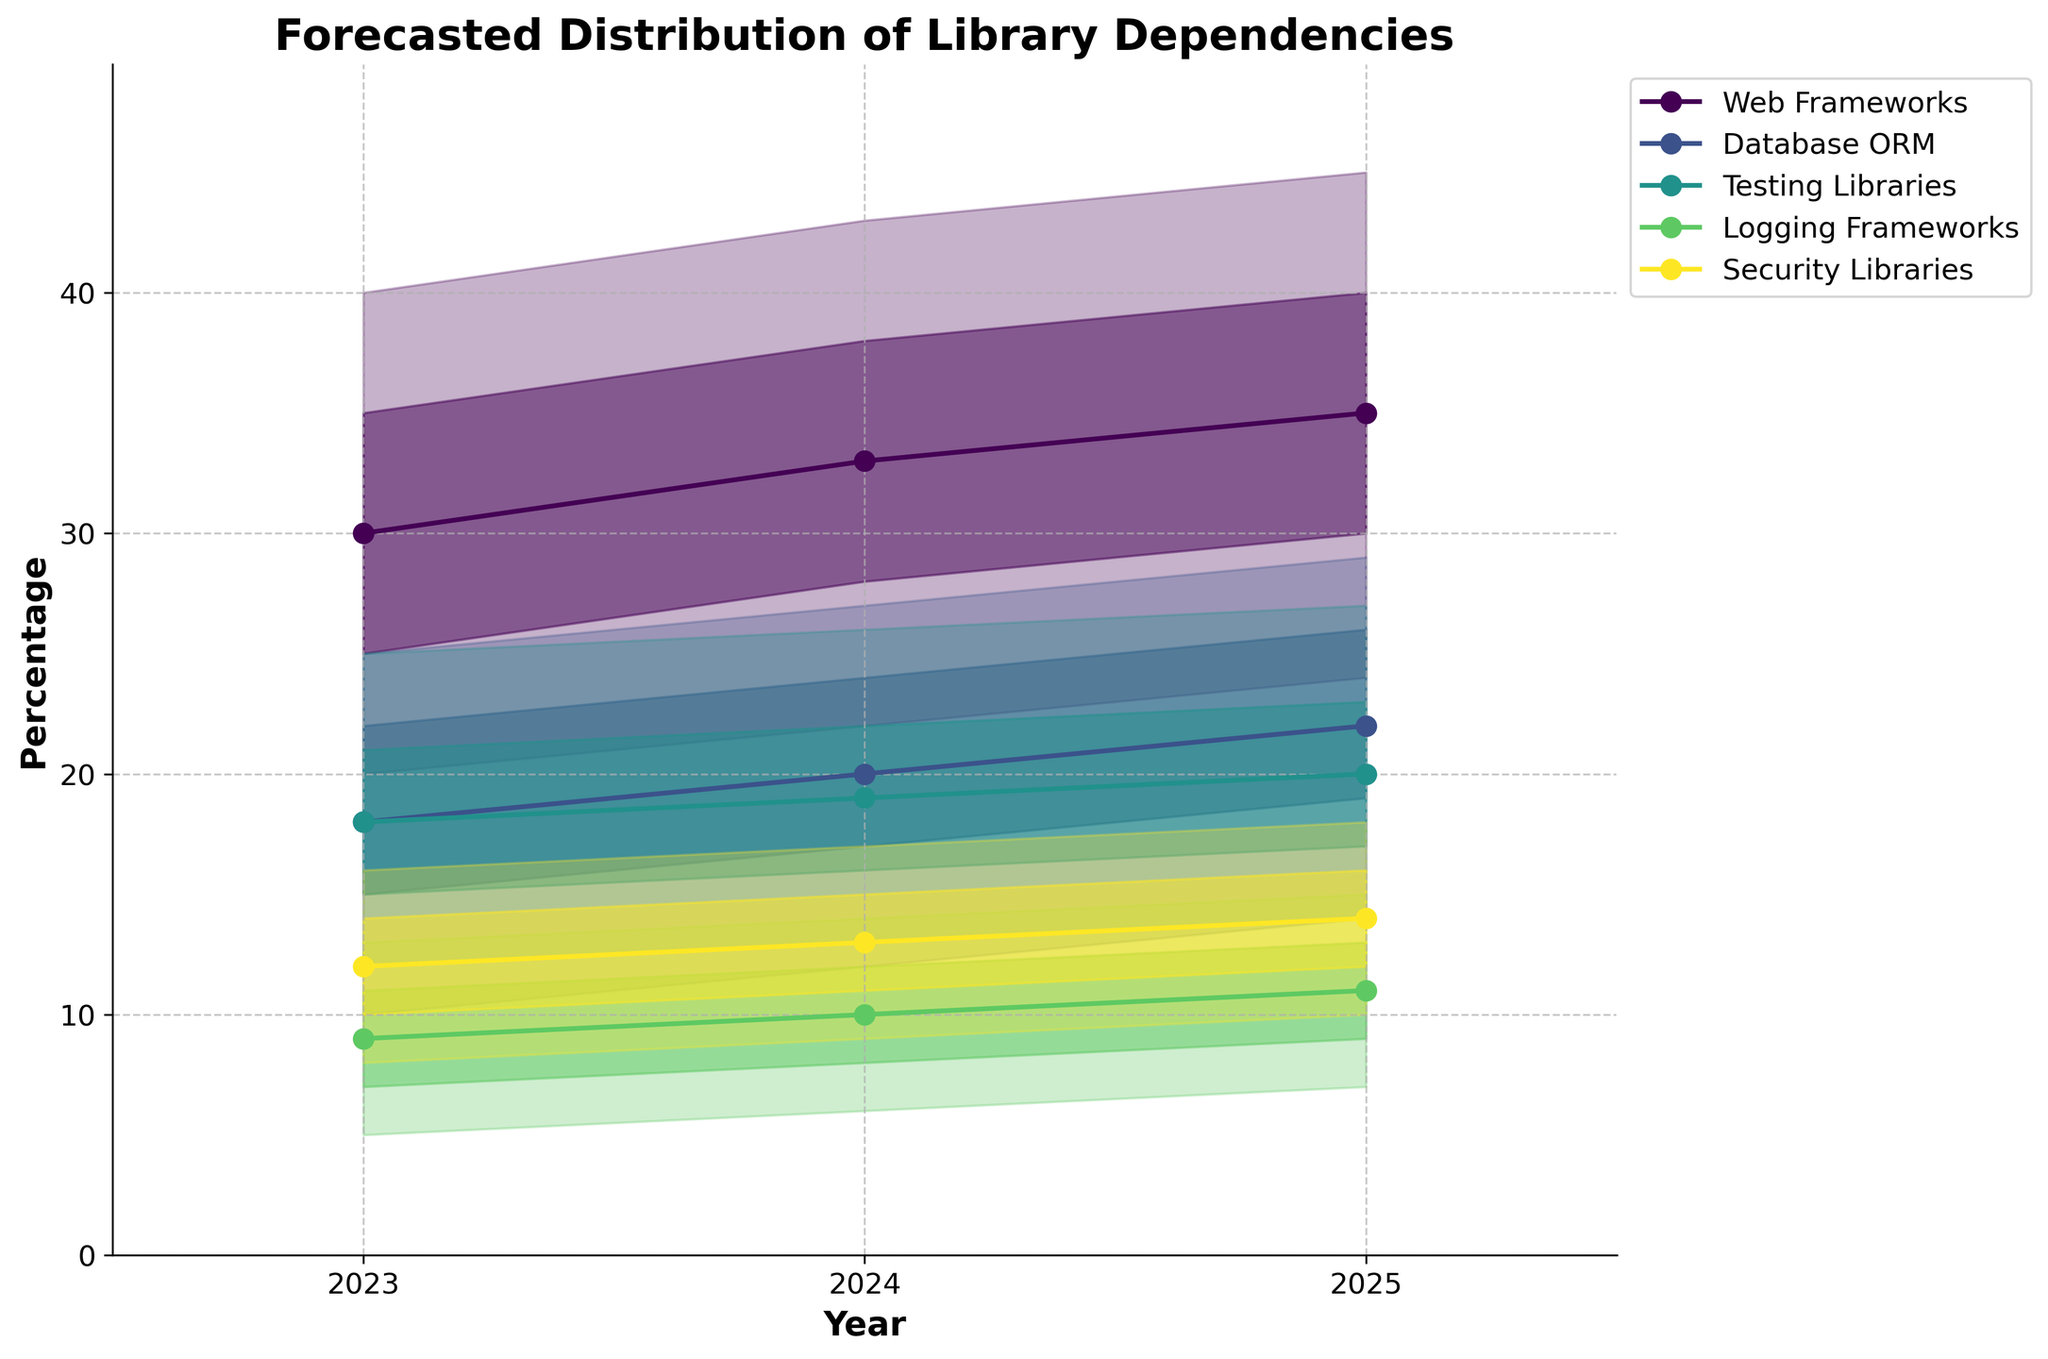what's the title of the figure? The title of the figure is typically displayed at the top of the chart. We can see it written as 'Forecasted Distribution of Library Dependencies'.
Answer: Forecasted Distribution of Library Dependencies what are the labels on the x-axis and y-axis? The x-axis label is displayed horizontally at the bottom, and it reads 'Year'. The y-axis label is displayed vertically on the left, and it reads 'Percentage'.
Answer: Year, Percentage which library category has the highest projected dependency for the year 2024? By looking at the topmost line in 2024, which represents the 'High' values, we can see that 'Web Frameworks' has the highest value of 43.
Answer: Web Frameworks what is the range of projected values for Testing Libraries in 2023? To find the range, we look at the bottom and top values for Testing Libraries in 2023, which are 12 and 25. Therefore, the range is the difference between these values, 25 - 12 = 13.
Answer: 13 how does the forecasted dependency of Database ORM change from 2023 to 2025? To observe the change, we compare the 'Mid' values for Database ORM in 2023 and 2025. In 2023, it is 18, and in 2025, it is 22. The change is an increase of 22 - 18 = 4.
Answer: Increases by 4 which year shows the narrowest range for Security Libraries, and what is the range? By comparing the range of 'Low' to 'High' values for Security Libraries for each year: 2023 (8-16), 2024 (9-17), 2025 (10-18), the year 2023 has the narrowest range of 16 - 8 = 8.
Answer: 2023, 8 how do the projected values for Logging Frameworks compare from 2023 to 2025? Comparing the 'Mid' values of Logging Frameworks for 2023 (9) and 2025 (11), we see an increase. The difference is 11 - 9 = 2.
Answer: Increase by 2 what trends can be observed for the Web Frameworks between 2023 and 2025? Observing the 'Mid' values of Web Frameworks from 2023 (30), 2024 (33), and 2025 (35), we can see an upward trend, indicating a steady increase in dependency.
Answer: Steady increase how many major categories are there in the figure, and what are they? The number of major categories can be determined by counting the unique labels in the legend or the y-axis. There are five: 'Web Frameworks', 'Database ORM', 'Testing Libraries', 'Logging Frameworks', and 'Security Libraries'.
Answer: Five, Web Frameworks, Database ORM, Testing Libraries, Logging Frameworks, Security Libraries which category shows the most variability in projected values in 2025? By observing the 'Low' to 'High' values for each category in 2025, 'Web Frameworks' has the most variability with a range from 24 to 45.
Answer: Web Frameworks 